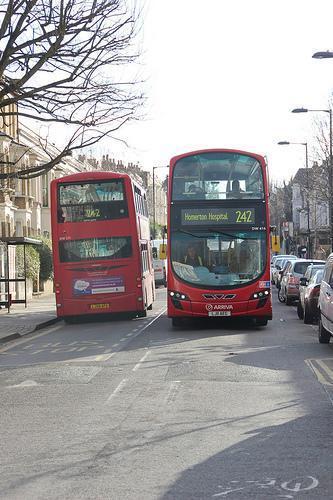How many busses?
Give a very brief answer. 2. How many light poles?
Give a very brief answer. 3. 